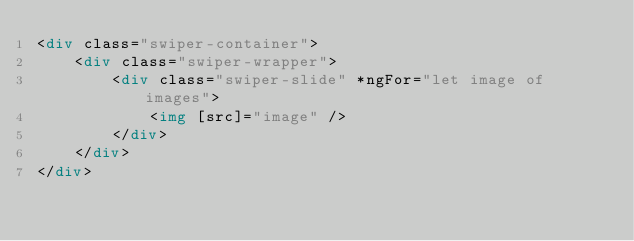Convert code to text. <code><loc_0><loc_0><loc_500><loc_500><_HTML_><div class="swiper-container">
    <div class="swiper-wrapper">
        <div class="swiper-slide" *ngFor="let image of images">
            <img [src]="image" />
        </div>
    </div>
</div></code> 